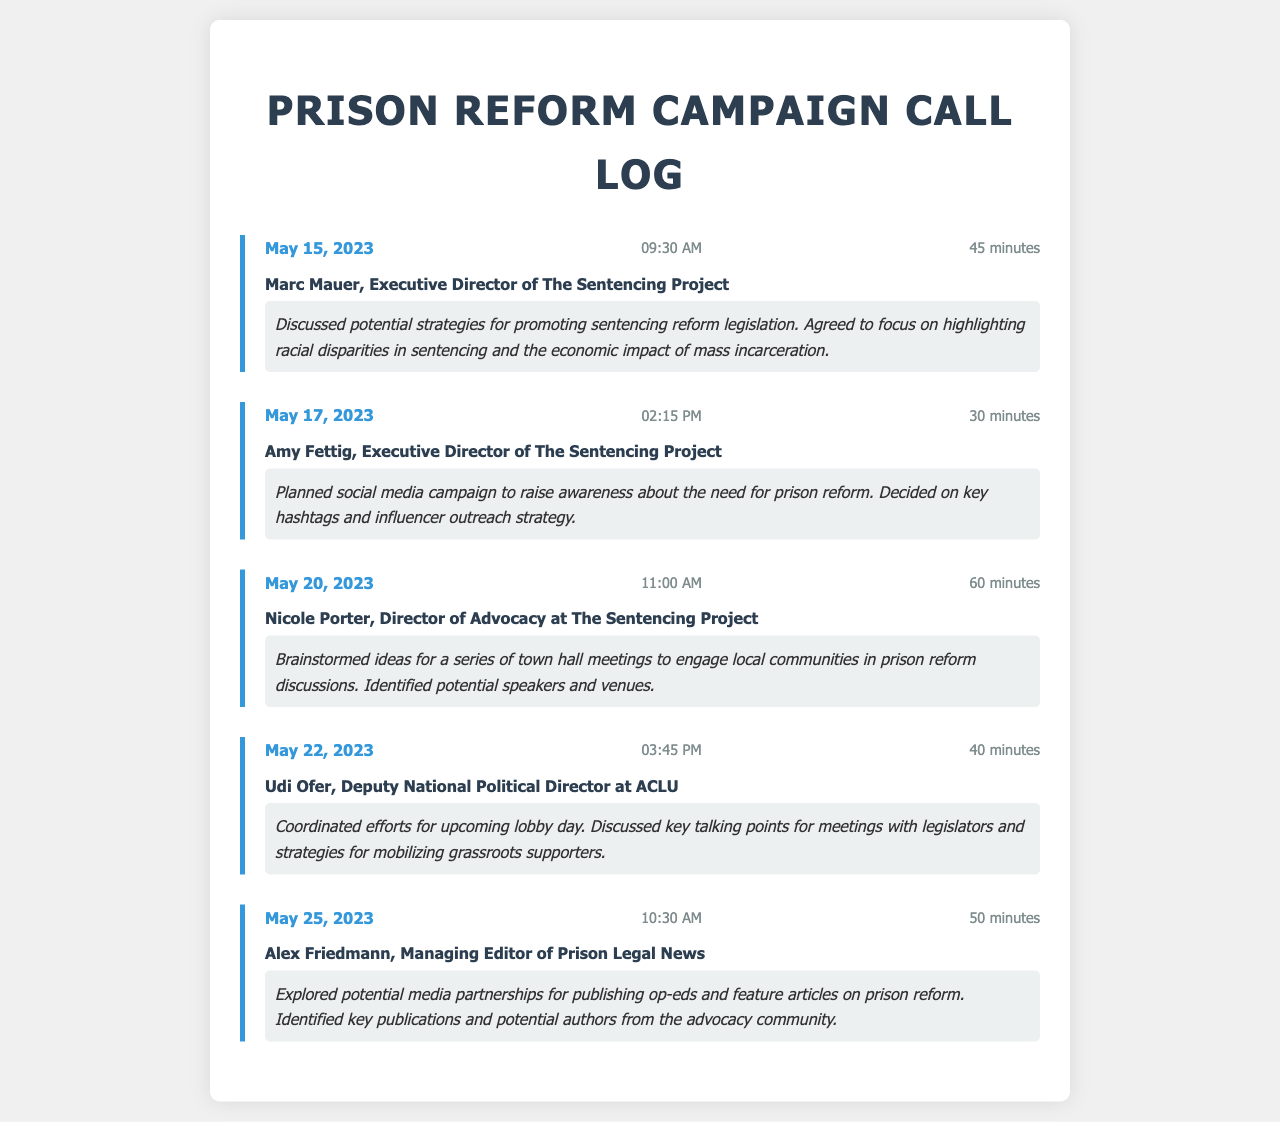What is the date of the call with Marc Mauer? The call with Marc Mauer took place on May 15, 2023.
Answer: May 15, 2023 How long did the call with Amy Fettig last? The call with Amy Fettig lasted for 30 minutes.
Answer: 30 minutes Who is the contact for the call on May 22, 2023? The contact for the call on May 22, 2023, was Udi Ofer.
Answer: Udi Ofer What was discussed in the call with Nicole Porter? In the call with Nicole Porter, ideas for town hall meetings to engage local communities were brainstormed.
Answer: Town hall meetings How many minutes was the longest call recorded? The longest call recorded lasted for 60 minutes.
Answer: 60 minutes What key strategy was mentioned in the call with Marc Mauer? The key strategy discussed with Marc Mauer was focusing on racial disparities in sentencing.
Answer: Racial disparities in sentencing What was the primary purpose of the call with Alex Friedmann? The primary purpose of the call with Alex Friedmann was to explore media partnerships for publishing on prison reform.
Answer: Media partnerships How many calls were made in total as per the log? There were a total of five calls logged in the document.
Answer: Five calls What is the time duration of the call with Udi Ofer? The call with Udi Ofer lasted for 40 minutes.
Answer: 40 minutes 